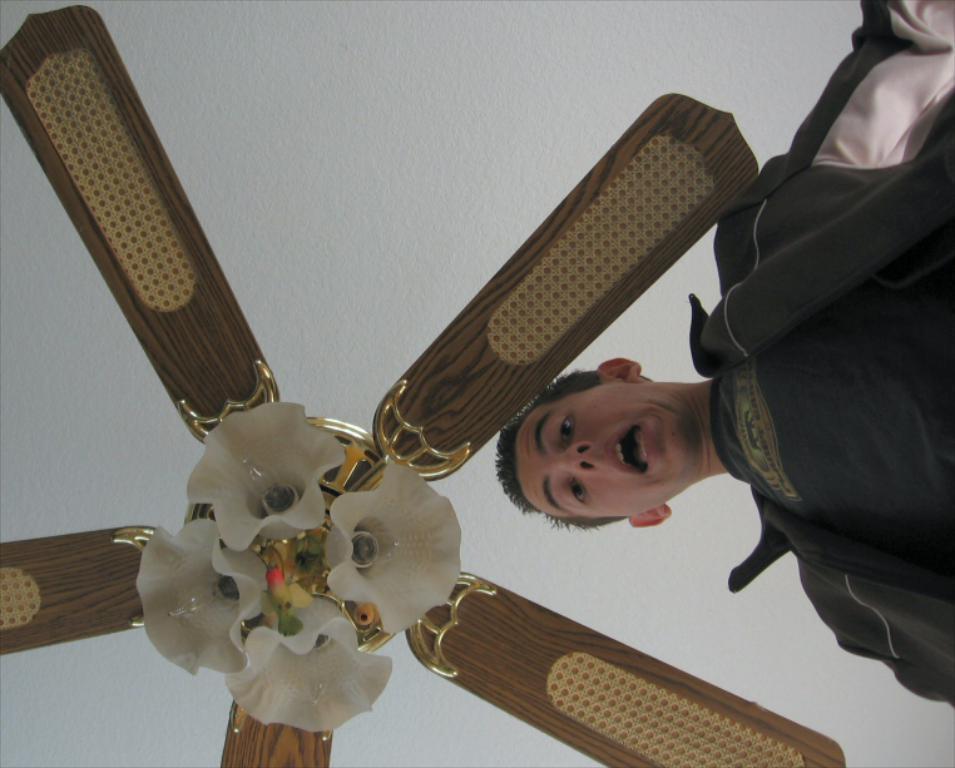Can you describe this image briefly? In the image there is a man looking downwards and above the man there is a fan. 